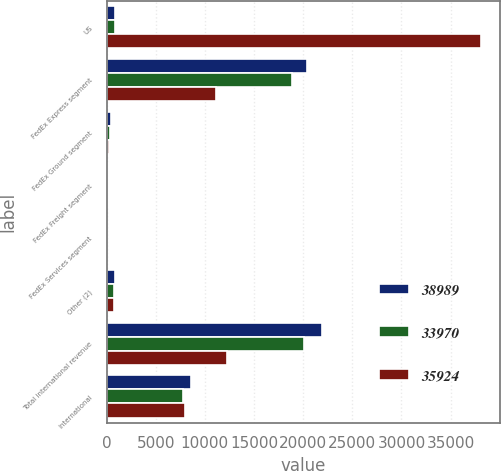Convert chart to OTSL. <chart><loc_0><loc_0><loc_500><loc_500><stacked_bar_chart><ecel><fcel>US<fcel>FedEx Express segment<fcel>FedEx Ground segment<fcel>FedEx Freight segment<fcel>FedEx Services segment<fcel>Other (2)<fcel>Total international revenue<fcel>International<nl><fcel>38989<fcel>825.5<fcel>20417<fcel>407<fcel>181<fcel>3<fcel>861<fcel>21869<fcel>8627<nl><fcel>33970<fcel>825.5<fcel>18817<fcel>331<fcel>149<fcel>10<fcel>743<fcel>20050<fcel>7783<nl><fcel>35924<fcel>38070<fcel>11083<fcel>275<fcel>137<fcel>10<fcel>790<fcel>12295<fcel>8028<nl></chart> 